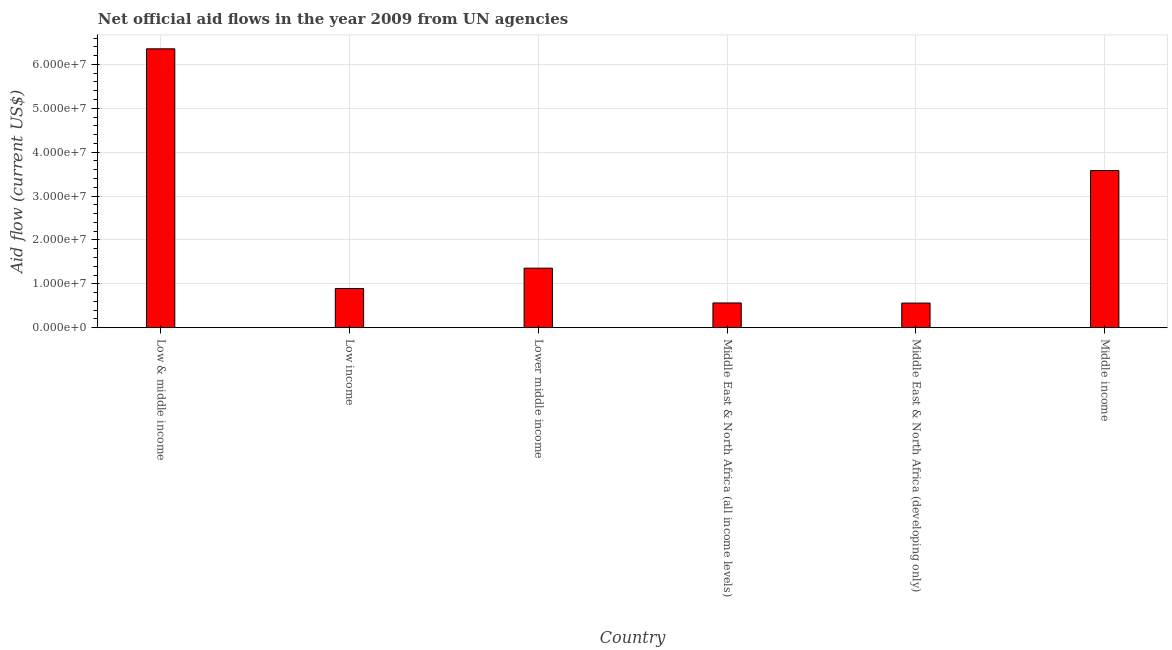What is the title of the graph?
Your answer should be compact. Net official aid flows in the year 2009 from UN agencies. What is the label or title of the X-axis?
Your answer should be compact. Country. What is the net official flows from un agencies in Middle income?
Your answer should be compact. 3.58e+07. Across all countries, what is the maximum net official flows from un agencies?
Provide a short and direct response. 6.36e+07. Across all countries, what is the minimum net official flows from un agencies?
Offer a terse response. 5.60e+06. In which country was the net official flows from un agencies minimum?
Provide a short and direct response. Middle East & North Africa (developing only). What is the sum of the net official flows from un agencies?
Provide a short and direct response. 1.33e+08. What is the difference between the net official flows from un agencies in Low income and Lower middle income?
Your response must be concise. -4.64e+06. What is the average net official flows from un agencies per country?
Provide a short and direct response. 2.22e+07. What is the median net official flows from un agencies?
Provide a succinct answer. 1.12e+07. In how many countries, is the net official flows from un agencies greater than 34000000 US$?
Offer a very short reply. 2. What is the ratio of the net official flows from un agencies in Low & middle income to that in Lower middle income?
Give a very brief answer. 4.69. Is the net official flows from un agencies in Low & middle income less than that in Lower middle income?
Offer a very short reply. No. Is the difference between the net official flows from un agencies in Low income and Middle income greater than the difference between any two countries?
Offer a very short reply. No. What is the difference between the highest and the second highest net official flows from un agencies?
Provide a succinct answer. 2.77e+07. Is the sum of the net official flows from un agencies in Low & middle income and Low income greater than the maximum net official flows from un agencies across all countries?
Offer a terse response. Yes. What is the difference between the highest and the lowest net official flows from un agencies?
Offer a very short reply. 5.80e+07. How many bars are there?
Your response must be concise. 6. Are all the bars in the graph horizontal?
Provide a short and direct response. No. What is the Aid flow (current US$) of Low & middle income?
Make the answer very short. 6.36e+07. What is the Aid flow (current US$) of Low income?
Your answer should be compact. 8.92e+06. What is the Aid flow (current US$) of Lower middle income?
Your response must be concise. 1.36e+07. What is the Aid flow (current US$) of Middle East & North Africa (all income levels)?
Your answer should be compact. 5.63e+06. What is the Aid flow (current US$) of Middle East & North Africa (developing only)?
Offer a terse response. 5.60e+06. What is the Aid flow (current US$) in Middle income?
Offer a very short reply. 3.58e+07. What is the difference between the Aid flow (current US$) in Low & middle income and Low income?
Give a very brief answer. 5.46e+07. What is the difference between the Aid flow (current US$) in Low & middle income and Lower middle income?
Make the answer very short. 5.00e+07. What is the difference between the Aid flow (current US$) in Low & middle income and Middle East & North Africa (all income levels)?
Your answer should be compact. 5.79e+07. What is the difference between the Aid flow (current US$) in Low & middle income and Middle East & North Africa (developing only)?
Make the answer very short. 5.80e+07. What is the difference between the Aid flow (current US$) in Low & middle income and Middle income?
Offer a terse response. 2.77e+07. What is the difference between the Aid flow (current US$) in Low income and Lower middle income?
Your answer should be very brief. -4.64e+06. What is the difference between the Aid flow (current US$) in Low income and Middle East & North Africa (all income levels)?
Your response must be concise. 3.29e+06. What is the difference between the Aid flow (current US$) in Low income and Middle East & North Africa (developing only)?
Make the answer very short. 3.32e+06. What is the difference between the Aid flow (current US$) in Low income and Middle income?
Ensure brevity in your answer.  -2.69e+07. What is the difference between the Aid flow (current US$) in Lower middle income and Middle East & North Africa (all income levels)?
Provide a short and direct response. 7.93e+06. What is the difference between the Aid flow (current US$) in Lower middle income and Middle East & North Africa (developing only)?
Your answer should be very brief. 7.96e+06. What is the difference between the Aid flow (current US$) in Lower middle income and Middle income?
Keep it short and to the point. -2.22e+07. What is the difference between the Aid flow (current US$) in Middle East & North Africa (all income levels) and Middle income?
Provide a succinct answer. -3.02e+07. What is the difference between the Aid flow (current US$) in Middle East & North Africa (developing only) and Middle income?
Provide a succinct answer. -3.02e+07. What is the ratio of the Aid flow (current US$) in Low & middle income to that in Low income?
Make the answer very short. 7.12. What is the ratio of the Aid flow (current US$) in Low & middle income to that in Lower middle income?
Keep it short and to the point. 4.69. What is the ratio of the Aid flow (current US$) in Low & middle income to that in Middle East & North Africa (all income levels)?
Ensure brevity in your answer.  11.29. What is the ratio of the Aid flow (current US$) in Low & middle income to that in Middle East & North Africa (developing only)?
Offer a very short reply. 11.35. What is the ratio of the Aid flow (current US$) in Low & middle income to that in Middle income?
Provide a succinct answer. 1.77. What is the ratio of the Aid flow (current US$) in Low income to that in Lower middle income?
Provide a succinct answer. 0.66. What is the ratio of the Aid flow (current US$) in Low income to that in Middle East & North Africa (all income levels)?
Your response must be concise. 1.58. What is the ratio of the Aid flow (current US$) in Low income to that in Middle East & North Africa (developing only)?
Make the answer very short. 1.59. What is the ratio of the Aid flow (current US$) in Low income to that in Middle income?
Your answer should be very brief. 0.25. What is the ratio of the Aid flow (current US$) in Lower middle income to that in Middle East & North Africa (all income levels)?
Keep it short and to the point. 2.41. What is the ratio of the Aid flow (current US$) in Lower middle income to that in Middle East & North Africa (developing only)?
Ensure brevity in your answer.  2.42. What is the ratio of the Aid flow (current US$) in Lower middle income to that in Middle income?
Provide a short and direct response. 0.38. What is the ratio of the Aid flow (current US$) in Middle East & North Africa (all income levels) to that in Middle income?
Provide a short and direct response. 0.16. What is the ratio of the Aid flow (current US$) in Middle East & North Africa (developing only) to that in Middle income?
Ensure brevity in your answer.  0.16. 